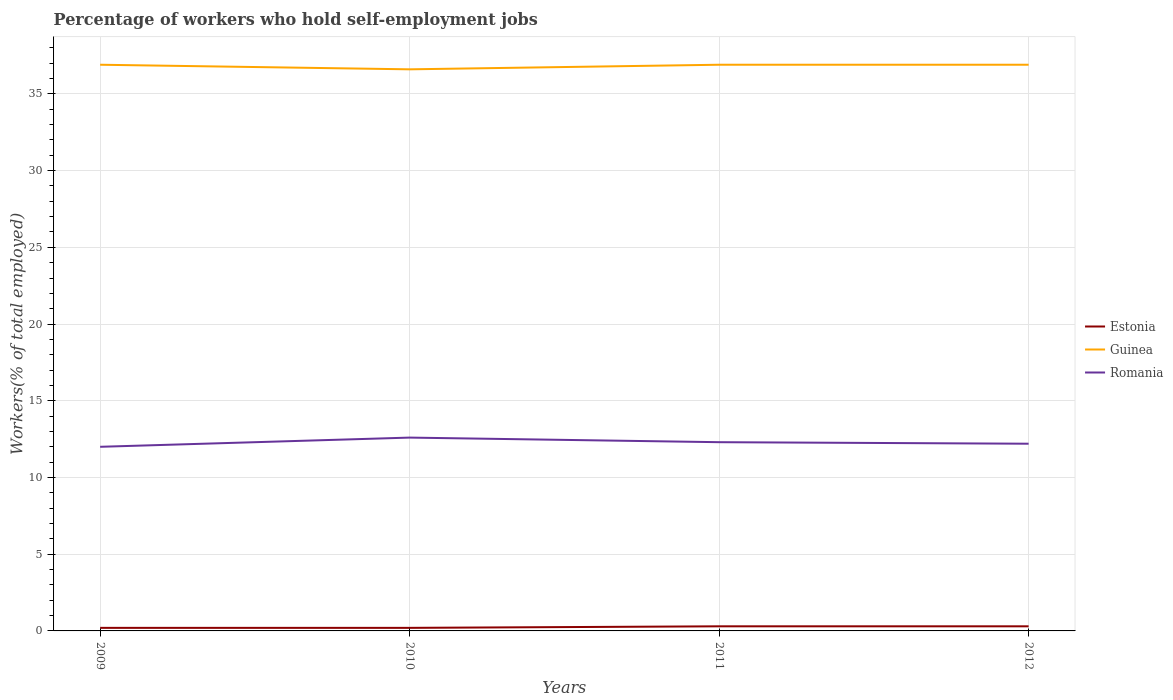Across all years, what is the maximum percentage of self-employed workers in Estonia?
Your answer should be compact. 0.2. What is the total percentage of self-employed workers in Romania in the graph?
Your response must be concise. -0.3. What is the difference between the highest and the second highest percentage of self-employed workers in Romania?
Provide a succinct answer. 0.6. What is the difference between the highest and the lowest percentage of self-employed workers in Romania?
Your response must be concise. 2. Is the percentage of self-employed workers in Romania strictly greater than the percentage of self-employed workers in Guinea over the years?
Provide a succinct answer. Yes. How many lines are there?
Your answer should be very brief. 3. What is the difference between two consecutive major ticks on the Y-axis?
Make the answer very short. 5. Are the values on the major ticks of Y-axis written in scientific E-notation?
Give a very brief answer. No. Does the graph contain grids?
Make the answer very short. Yes. Where does the legend appear in the graph?
Your response must be concise. Center right. How many legend labels are there?
Make the answer very short. 3. How are the legend labels stacked?
Give a very brief answer. Vertical. What is the title of the graph?
Your answer should be compact. Percentage of workers who hold self-employment jobs. What is the label or title of the X-axis?
Offer a terse response. Years. What is the label or title of the Y-axis?
Offer a very short reply. Workers(% of total employed). What is the Workers(% of total employed) in Estonia in 2009?
Provide a succinct answer. 0.2. What is the Workers(% of total employed) in Guinea in 2009?
Offer a terse response. 36.9. What is the Workers(% of total employed) of Romania in 2009?
Your response must be concise. 12. What is the Workers(% of total employed) of Estonia in 2010?
Ensure brevity in your answer.  0.2. What is the Workers(% of total employed) in Guinea in 2010?
Offer a terse response. 36.6. What is the Workers(% of total employed) in Romania in 2010?
Ensure brevity in your answer.  12.6. What is the Workers(% of total employed) of Estonia in 2011?
Ensure brevity in your answer.  0.3. What is the Workers(% of total employed) in Guinea in 2011?
Your answer should be compact. 36.9. What is the Workers(% of total employed) of Romania in 2011?
Your answer should be compact. 12.3. What is the Workers(% of total employed) in Estonia in 2012?
Provide a succinct answer. 0.3. What is the Workers(% of total employed) in Guinea in 2012?
Give a very brief answer. 36.9. What is the Workers(% of total employed) in Romania in 2012?
Provide a short and direct response. 12.2. Across all years, what is the maximum Workers(% of total employed) of Estonia?
Ensure brevity in your answer.  0.3. Across all years, what is the maximum Workers(% of total employed) of Guinea?
Your answer should be very brief. 36.9. Across all years, what is the maximum Workers(% of total employed) in Romania?
Your response must be concise. 12.6. Across all years, what is the minimum Workers(% of total employed) in Estonia?
Your answer should be compact. 0.2. Across all years, what is the minimum Workers(% of total employed) of Guinea?
Provide a short and direct response. 36.6. What is the total Workers(% of total employed) of Guinea in the graph?
Your answer should be very brief. 147.3. What is the total Workers(% of total employed) of Romania in the graph?
Make the answer very short. 49.1. What is the difference between the Workers(% of total employed) of Romania in 2009 and that in 2011?
Provide a succinct answer. -0.3. What is the difference between the Workers(% of total employed) of Guinea in 2010 and that in 2011?
Your response must be concise. -0.3. What is the difference between the Workers(% of total employed) in Romania in 2010 and that in 2011?
Give a very brief answer. 0.3. What is the difference between the Workers(% of total employed) of Estonia in 2010 and that in 2012?
Your response must be concise. -0.1. What is the difference between the Workers(% of total employed) in Romania in 2010 and that in 2012?
Offer a terse response. 0.4. What is the difference between the Workers(% of total employed) of Romania in 2011 and that in 2012?
Your answer should be compact. 0.1. What is the difference between the Workers(% of total employed) in Estonia in 2009 and the Workers(% of total employed) in Guinea in 2010?
Your answer should be compact. -36.4. What is the difference between the Workers(% of total employed) in Estonia in 2009 and the Workers(% of total employed) in Romania in 2010?
Your response must be concise. -12.4. What is the difference between the Workers(% of total employed) of Guinea in 2009 and the Workers(% of total employed) of Romania in 2010?
Offer a very short reply. 24.3. What is the difference between the Workers(% of total employed) in Estonia in 2009 and the Workers(% of total employed) in Guinea in 2011?
Your answer should be compact. -36.7. What is the difference between the Workers(% of total employed) of Estonia in 2009 and the Workers(% of total employed) of Romania in 2011?
Offer a very short reply. -12.1. What is the difference between the Workers(% of total employed) of Guinea in 2009 and the Workers(% of total employed) of Romania in 2011?
Give a very brief answer. 24.6. What is the difference between the Workers(% of total employed) of Estonia in 2009 and the Workers(% of total employed) of Guinea in 2012?
Keep it short and to the point. -36.7. What is the difference between the Workers(% of total employed) of Estonia in 2009 and the Workers(% of total employed) of Romania in 2012?
Make the answer very short. -12. What is the difference between the Workers(% of total employed) in Guinea in 2009 and the Workers(% of total employed) in Romania in 2012?
Make the answer very short. 24.7. What is the difference between the Workers(% of total employed) of Estonia in 2010 and the Workers(% of total employed) of Guinea in 2011?
Your answer should be compact. -36.7. What is the difference between the Workers(% of total employed) of Estonia in 2010 and the Workers(% of total employed) of Romania in 2011?
Make the answer very short. -12.1. What is the difference between the Workers(% of total employed) of Guinea in 2010 and the Workers(% of total employed) of Romania in 2011?
Give a very brief answer. 24.3. What is the difference between the Workers(% of total employed) of Estonia in 2010 and the Workers(% of total employed) of Guinea in 2012?
Offer a terse response. -36.7. What is the difference between the Workers(% of total employed) of Guinea in 2010 and the Workers(% of total employed) of Romania in 2012?
Keep it short and to the point. 24.4. What is the difference between the Workers(% of total employed) of Estonia in 2011 and the Workers(% of total employed) of Guinea in 2012?
Provide a succinct answer. -36.6. What is the difference between the Workers(% of total employed) in Guinea in 2011 and the Workers(% of total employed) in Romania in 2012?
Make the answer very short. 24.7. What is the average Workers(% of total employed) of Estonia per year?
Your answer should be compact. 0.25. What is the average Workers(% of total employed) in Guinea per year?
Give a very brief answer. 36.83. What is the average Workers(% of total employed) of Romania per year?
Your response must be concise. 12.28. In the year 2009, what is the difference between the Workers(% of total employed) of Estonia and Workers(% of total employed) of Guinea?
Your answer should be compact. -36.7. In the year 2009, what is the difference between the Workers(% of total employed) in Guinea and Workers(% of total employed) in Romania?
Your response must be concise. 24.9. In the year 2010, what is the difference between the Workers(% of total employed) of Estonia and Workers(% of total employed) of Guinea?
Make the answer very short. -36.4. In the year 2010, what is the difference between the Workers(% of total employed) of Estonia and Workers(% of total employed) of Romania?
Your answer should be compact. -12.4. In the year 2010, what is the difference between the Workers(% of total employed) of Guinea and Workers(% of total employed) of Romania?
Keep it short and to the point. 24. In the year 2011, what is the difference between the Workers(% of total employed) of Estonia and Workers(% of total employed) of Guinea?
Give a very brief answer. -36.6. In the year 2011, what is the difference between the Workers(% of total employed) of Estonia and Workers(% of total employed) of Romania?
Offer a very short reply. -12. In the year 2011, what is the difference between the Workers(% of total employed) of Guinea and Workers(% of total employed) of Romania?
Make the answer very short. 24.6. In the year 2012, what is the difference between the Workers(% of total employed) of Estonia and Workers(% of total employed) of Guinea?
Provide a succinct answer. -36.6. In the year 2012, what is the difference between the Workers(% of total employed) in Guinea and Workers(% of total employed) in Romania?
Give a very brief answer. 24.7. What is the ratio of the Workers(% of total employed) in Guinea in 2009 to that in 2010?
Offer a very short reply. 1.01. What is the ratio of the Workers(% of total employed) of Estonia in 2009 to that in 2011?
Your response must be concise. 0.67. What is the ratio of the Workers(% of total employed) in Romania in 2009 to that in 2011?
Your answer should be compact. 0.98. What is the ratio of the Workers(% of total employed) in Romania in 2009 to that in 2012?
Provide a succinct answer. 0.98. What is the ratio of the Workers(% of total employed) of Romania in 2010 to that in 2011?
Make the answer very short. 1.02. What is the ratio of the Workers(% of total employed) of Romania in 2010 to that in 2012?
Provide a succinct answer. 1.03. What is the ratio of the Workers(% of total employed) in Estonia in 2011 to that in 2012?
Ensure brevity in your answer.  1. What is the ratio of the Workers(% of total employed) of Guinea in 2011 to that in 2012?
Give a very brief answer. 1. What is the ratio of the Workers(% of total employed) of Romania in 2011 to that in 2012?
Offer a terse response. 1.01. 